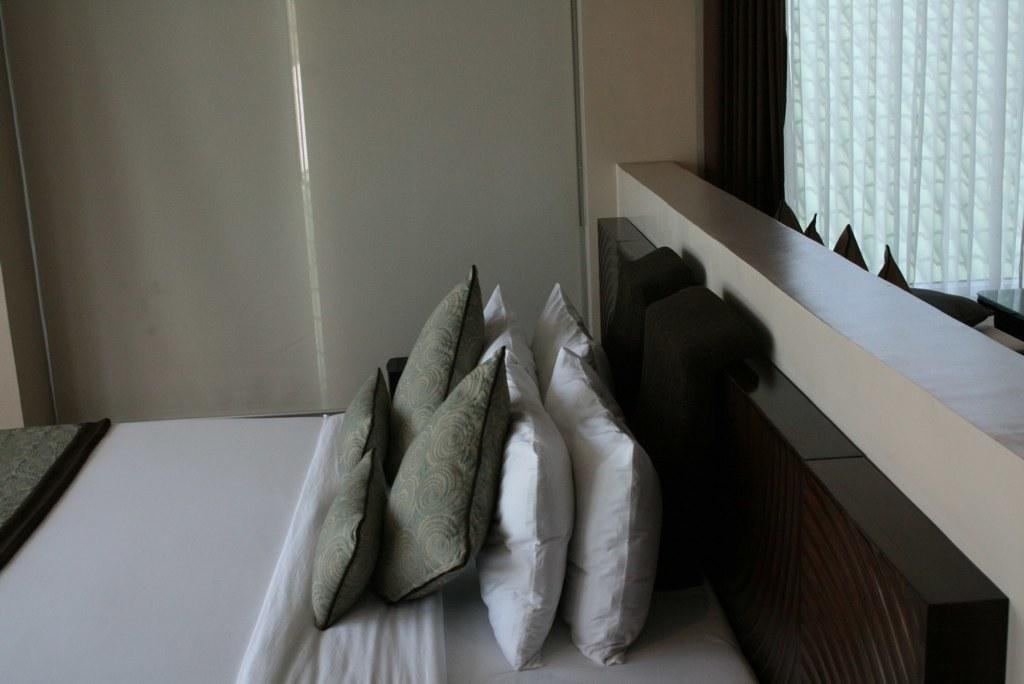What objects are present on the bed in the image? There are pillows on the bed in the image. What colors are the pillows? The pillows are in white and grey colors. What type of weather can be seen in the image? There is no weather visible in the image, as it only features pillows on a bed. 